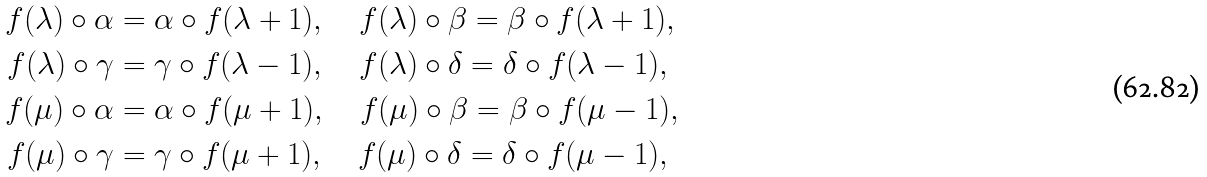Convert formula to latex. <formula><loc_0><loc_0><loc_500><loc_500>f ( \lambda ) \circ \alpha & = \alpha \circ f ( \lambda + 1 ) , \quad f ( \lambda ) \circ \beta = \beta \circ f ( \lambda + 1 ) , \\ f ( \lambda ) \circ \gamma & = \gamma \circ f ( \lambda - 1 ) , \quad f ( \lambda ) \circ \delta = \delta \circ f ( \lambda - 1 ) , \\ f ( \mu ) \circ \alpha & = \alpha \circ f ( \mu + 1 ) , \quad f ( \mu ) \circ \beta = \beta \circ f ( \mu - 1 ) , \\ f ( \mu ) \circ \gamma & = \gamma \circ f ( \mu + 1 ) , \quad f ( \mu ) \circ \delta = \delta \circ f ( \mu - 1 ) ,</formula> 